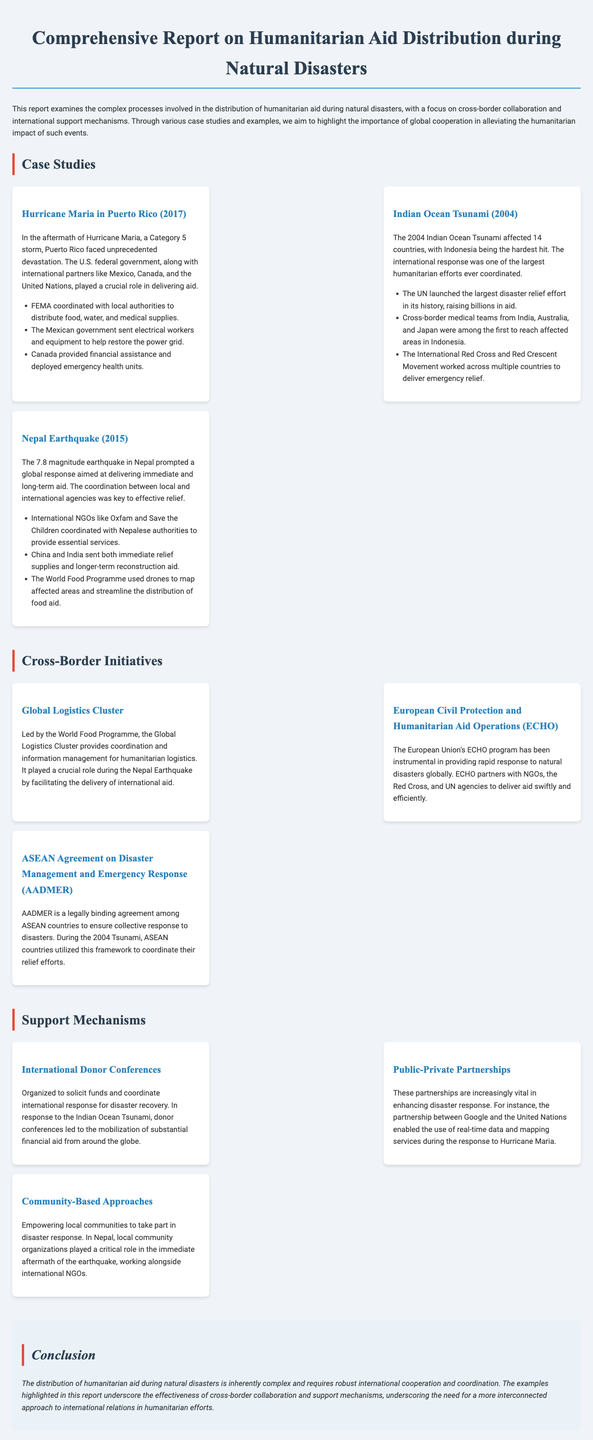what is the name of the natural disaster examined in Puerto Rico in 2017? The report highlights Hurricane Maria as the disaster in Puerto Rico.
Answer: Hurricane Maria how many countries were affected by the Indian Ocean Tsunami in 2004? The document states that the Indian Ocean Tsunami affected 14 countries.
Answer: 14 which international organization led the Global Logistics Cluster? The report specifies that the World Food Programme led the Global Logistics Cluster.
Answer: World Food Programme what type of agreement is AADMER? AADMER is described as a legally binding agreement among ASEAN countries.
Answer: legally binding agreement which countries sent immediate relief supplies during the Nepal Earthquake? The document mentions China and India sent both immediate relief supplies and longer-term reconstruction aid.
Answer: China and India what role did Google play during the response to Hurricane Maria? According to the report, Google partnered with the United Nations to enable the use of real-time data and mapping services.
Answer: real-time data and mapping services how did FEMA assist in Hurricane Maria relief efforts? FEMA coordinated with local authorities to distribute food, water, and medical supplies.
Answer: distribute food, water, and medical supplies what was the purpose of the international donor conferences? The report explains that these conferences were organized to solicit funds and coordinate international response.
Answer: solicit funds and coordinate international response 